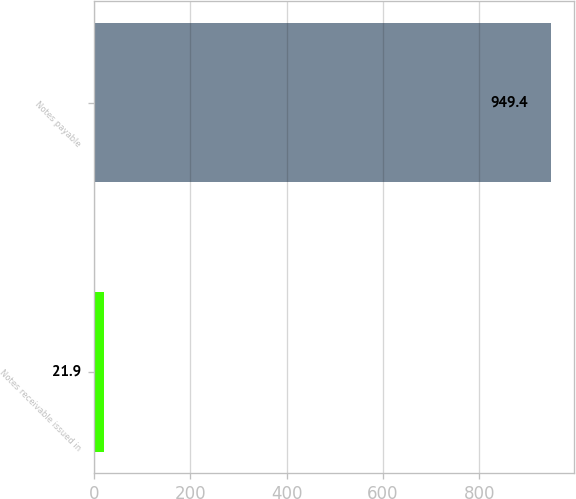Convert chart. <chart><loc_0><loc_0><loc_500><loc_500><bar_chart><fcel>Notes receivable issued in<fcel>Notes payable<nl><fcel>21.9<fcel>949.4<nl></chart> 